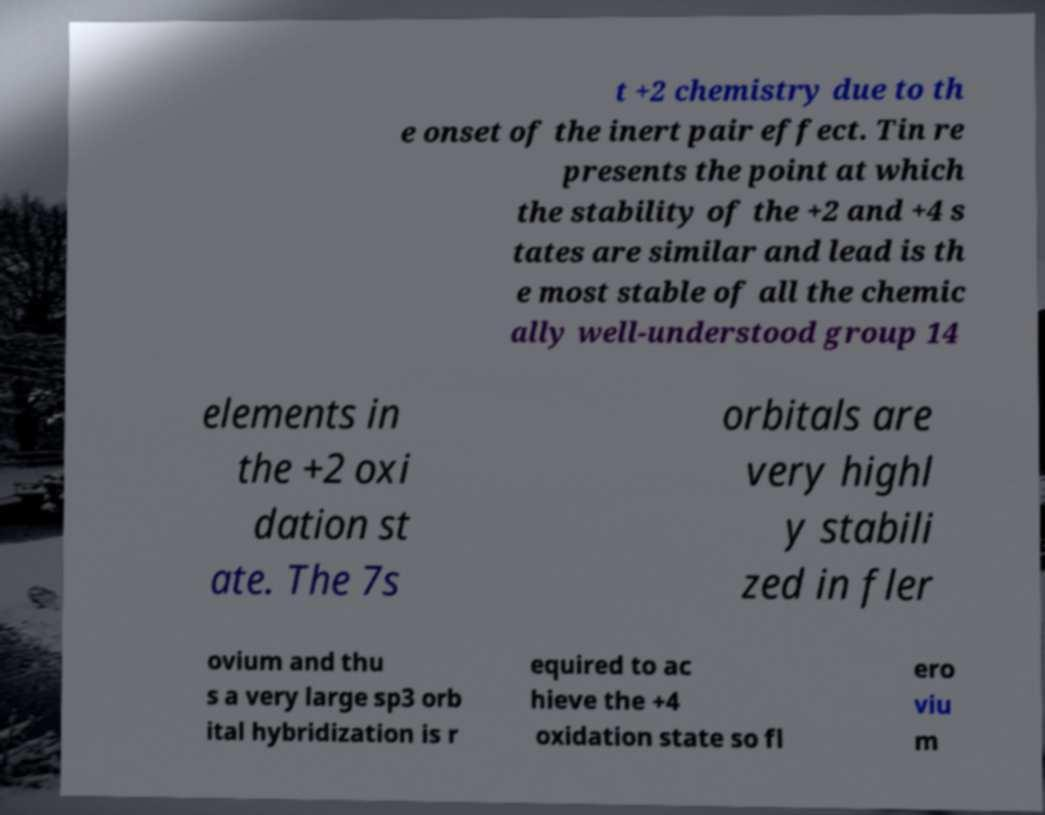Could you extract and type out the text from this image? t +2 chemistry due to th e onset of the inert pair effect. Tin re presents the point at which the stability of the +2 and +4 s tates are similar and lead is th e most stable of all the chemic ally well-understood group 14 elements in the +2 oxi dation st ate. The 7s orbitals are very highl y stabili zed in fler ovium and thu s a very large sp3 orb ital hybridization is r equired to ac hieve the +4 oxidation state so fl ero viu m 